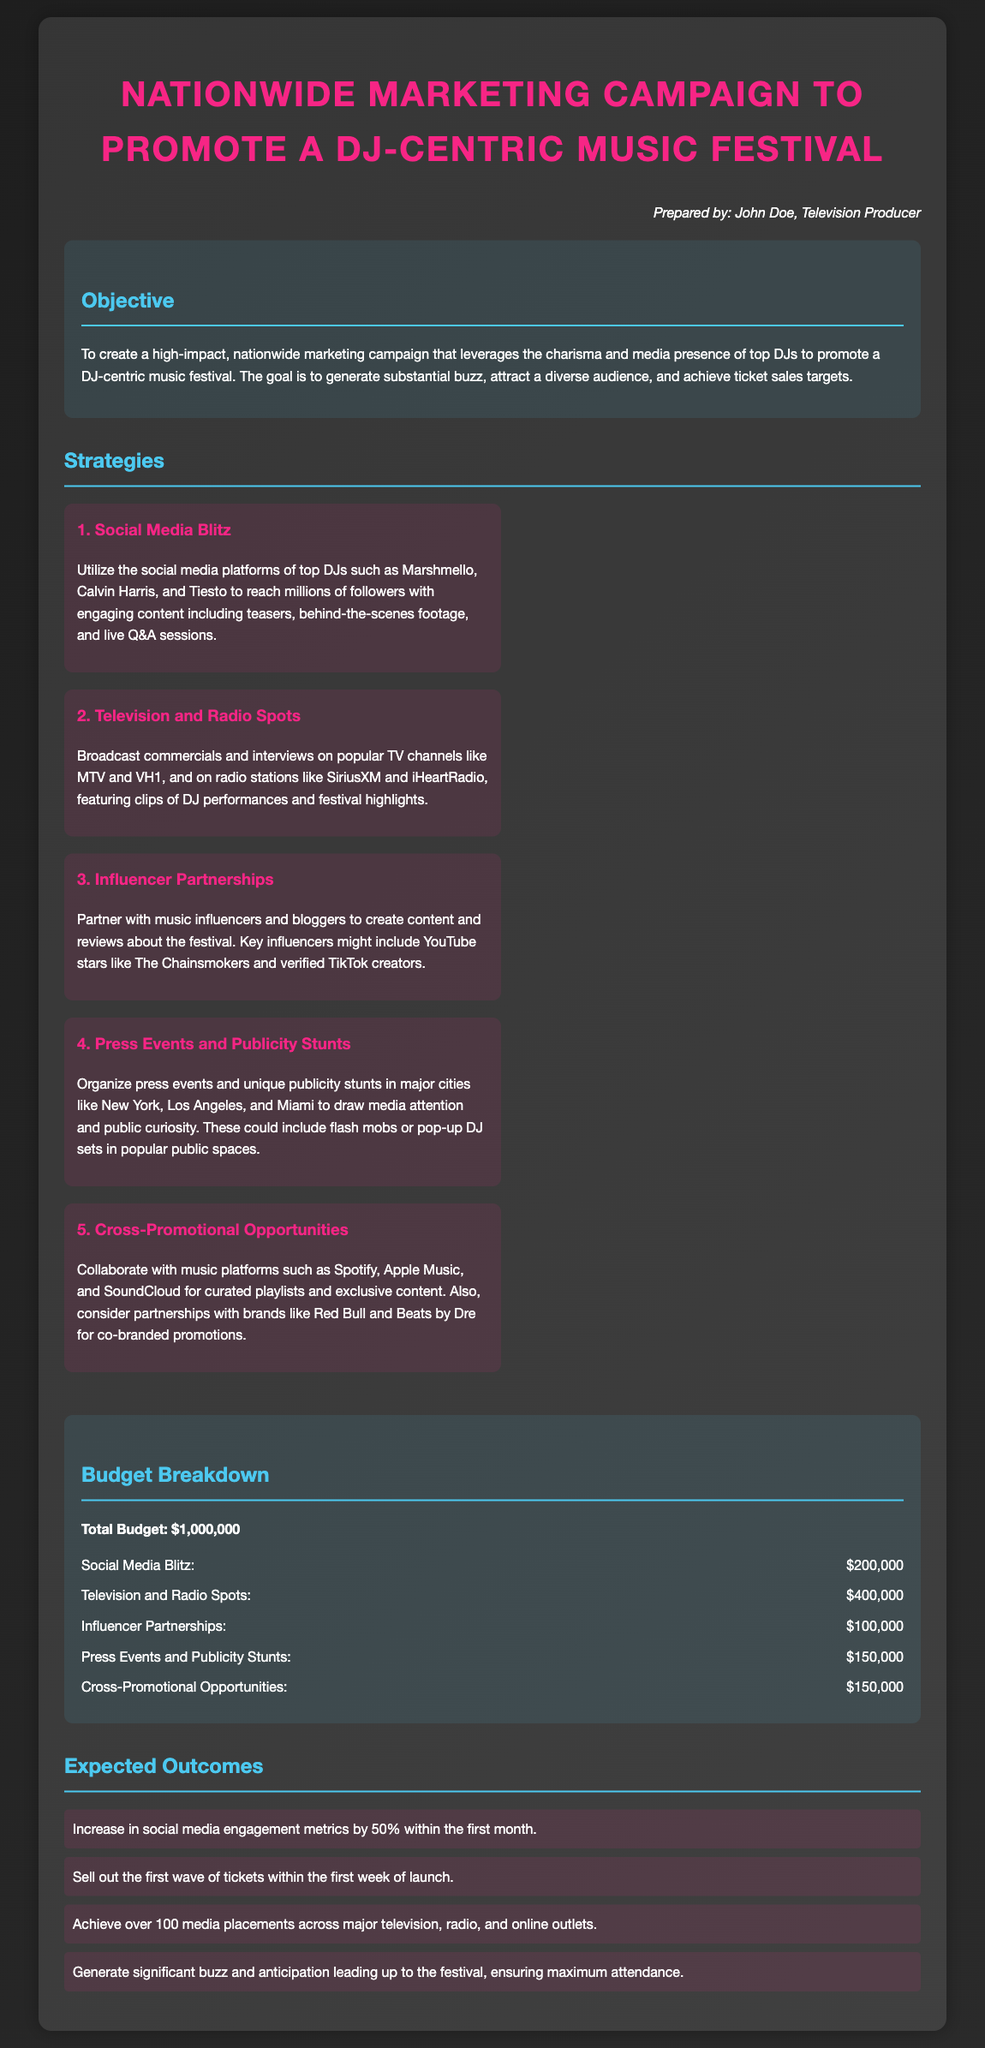What is the total budget for the marketing campaign? The total budget is explicitly stated in the document and summarizes the total expenditure for the campaign.
Answer: $1,000,000 Who is the campaign prepared by? The document includes a note at the top identifying the individual responsible for the proposal.
Answer: John Doe How much is allocated for Television and Radio Spots? The budget breakdown section lists the specific amounts allotted for each strategy in the campaign.
Answer: $400,000 What is one expected outcome of the marketing campaign? The outcomes section outlines the goals anticipated from the marketing efforts, representing key metrics for success.
Answer: Increase in social media engagement metrics by 50% within the first month Which DJs are mentioned in the Social Media Blitz strategy? The strategy section provides examples of specific DJs who will be featured to promote the festival, highlighting influential figures.
Answer: Marshmello, Calvin Harris, Tiesto What is the planned strategy for influencer marketing? The document details the strategy surrounding partnerships with influential figures in music and social media.
Answer: Influencer Partnerships What type of events are proposed to generate media attention? The proposal mentions certain tactics for raising public awareness through engaging activities and gatherings.
Answer: Press Events and Publicity Stunts What marketing approach uses behind-the-scenes footage? The clear description of the marketing strategies indicates specific methods of engaging the audience.
Answer: Social Media Blitz What is the budget amount for Press Events and Publicity Stunts? The budget breakdown explicitly mentions expenditure for specific activities, detailing the financial plan.
Answer: $150,000 